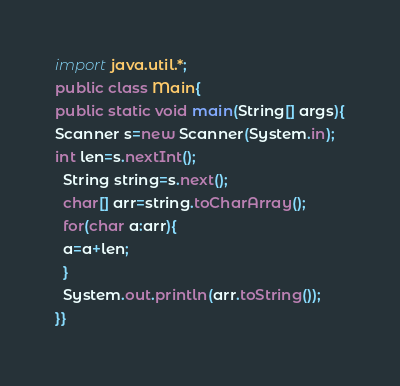Convert code to text. <code><loc_0><loc_0><loc_500><loc_500><_Java_>import java.util.*;
public class Main{
public static void main(String[] args){
Scanner s=new Scanner(System.in);
int len=s.nextInt();
  String string=s.next();
  char[] arr=string.toCharArray();
  for(char a:arr){
  a=a+len;
  }
  System.out.println(arr.toString());
}}</code> 